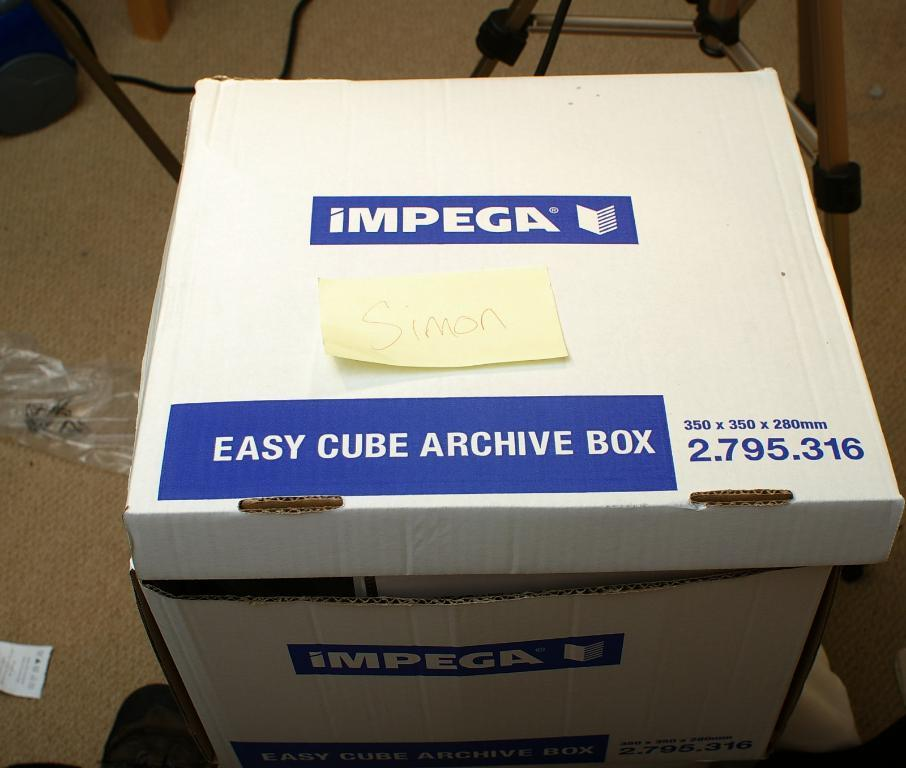Provide a one-sentence caption for the provided image. A blue and white cardboard box with easy cube archive box printed on it. 